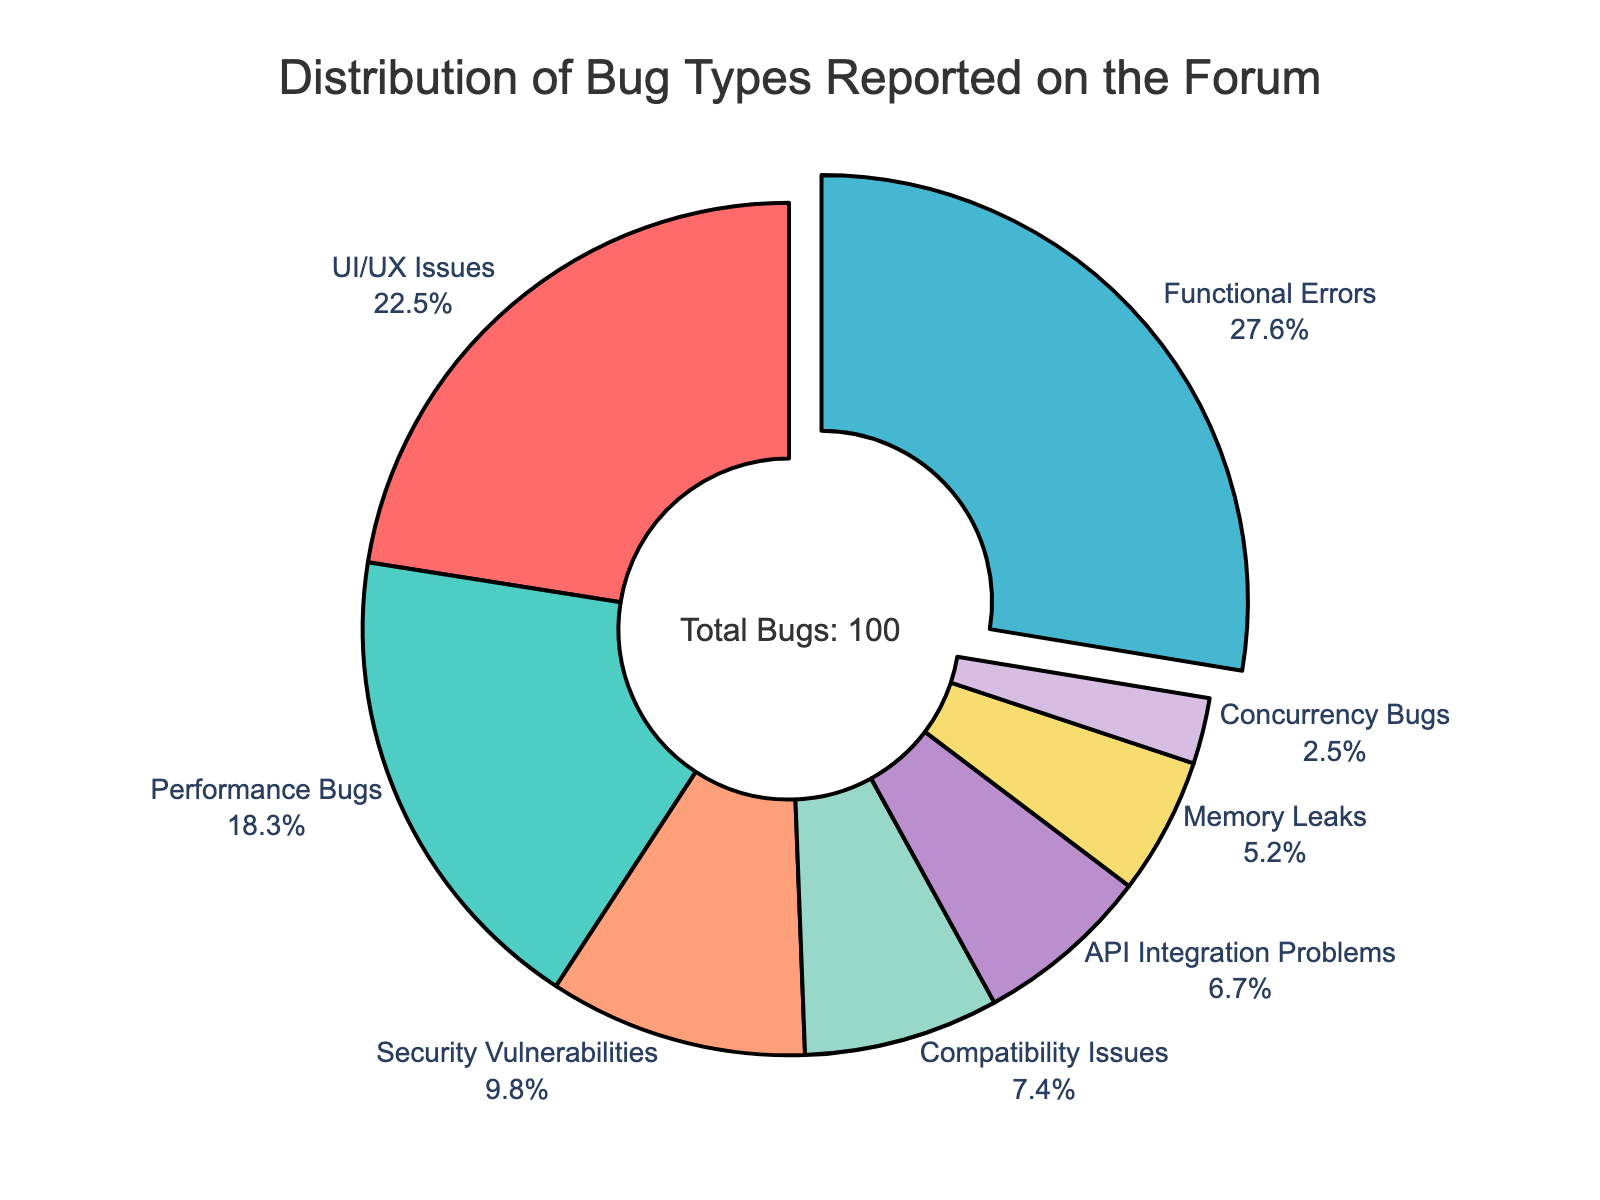What's the category with the highest percentage of bugs reported? First, look at the pie chart to identify the segment with the largest size and note its category. According to the data, Functional Errors occupy the largest segment.
Answer: Functional Errors Which two categories combined make up almost half of the reported bugs? Identify the percentages of each category and sum them to check if they make up nearly 50%. Functional Errors (27.6%) and UI/UX Issues (22.5%) together sum up to 50.1%.
Answer: Functional Errors and UI/UX Issues What is the combined percentage of Memory Leaks and Concurrency Bugs? Identify the percentages for Memory Leaks (5.2%) and Concurrency Bugs (2.5%) and sum them. 5.2 + 2.5 = 7.7.
Answer: 7.7% Which categories have a lower percentage of bugs reported compared to Performance Bugs? Performance Bugs are at 18.3%. Any category with a percentage lower than 18.3% qualifies. These are Security Vulnerabilities (9.8%), Compatibility Issues (7.4%), Memory Leaks (5.2%), API Integration Problems (6.7%), and Concurrency Bugs (2.5%).
Answer: Security Vulnerabilities, Compatibility Issues, Memory Leaks, API Integration Problems, Concurrency Bugs How do the percentages of API Integration Problems and Security Vulnerabilities compare? Compare their respective percentages. API Integration Problems are at 6.7% whereas Security Vulnerabilities are at 9.8%, so Security Vulnerabilities are higher.
Answer: Security Vulnerabilities are higher Which category has the smallest percentage of bugs reported? Look for the smallest segment in the pie chart. Concurrency Bugs have the smallest percentage at 2.5%.
Answer: Concurrency Bugs What percentage of bugs is attributed to UI/UX Issues compared to Performance Bugs? Compare the respective percentages: UI/UX Issues are at 22.5% and Performance Bugs are at 18.3%. Subtract Performance Bugs from UI/UX Issues to get the difference: 22.5 - 18.3 = 4.2%.
Answer: UI/UX Issues are 4.2% higher Is there a larger percentage of Compatibility Issues or Memory Leaks? Compare Compatibility Issues (7.4%) with Memory Leaks (5.2%). Compatibility Issues are higher.
Answer: Compatibility Issues How much higher is the percentage of Functional Errors compared to Memory Leaks? Subtract the percentage of Memory Leaks (5.2%) from Functional Errors (27.6%): 27.6 - 5.2 = 22.4%.
Answer: 22.4% higher 